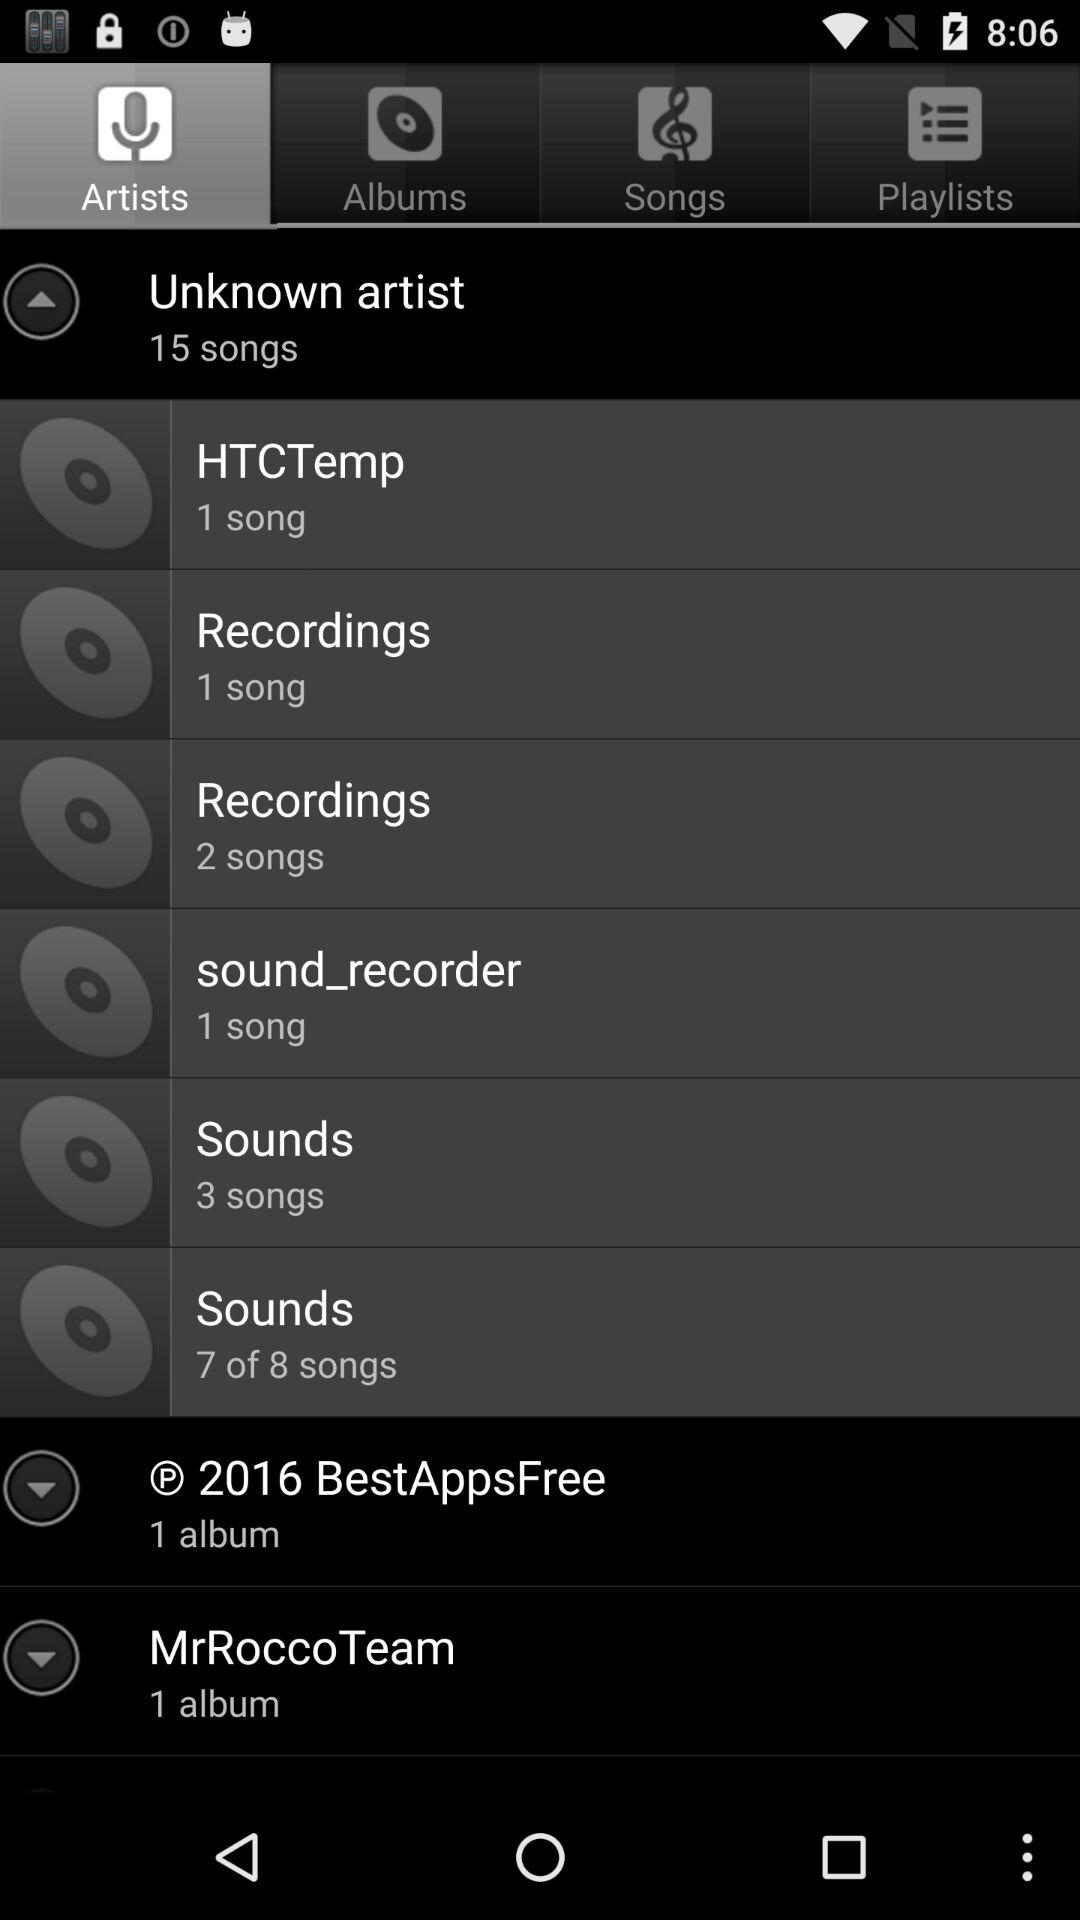How many songs are there in "Unknown artist"? There are 15 songs in "Unknown artist". 